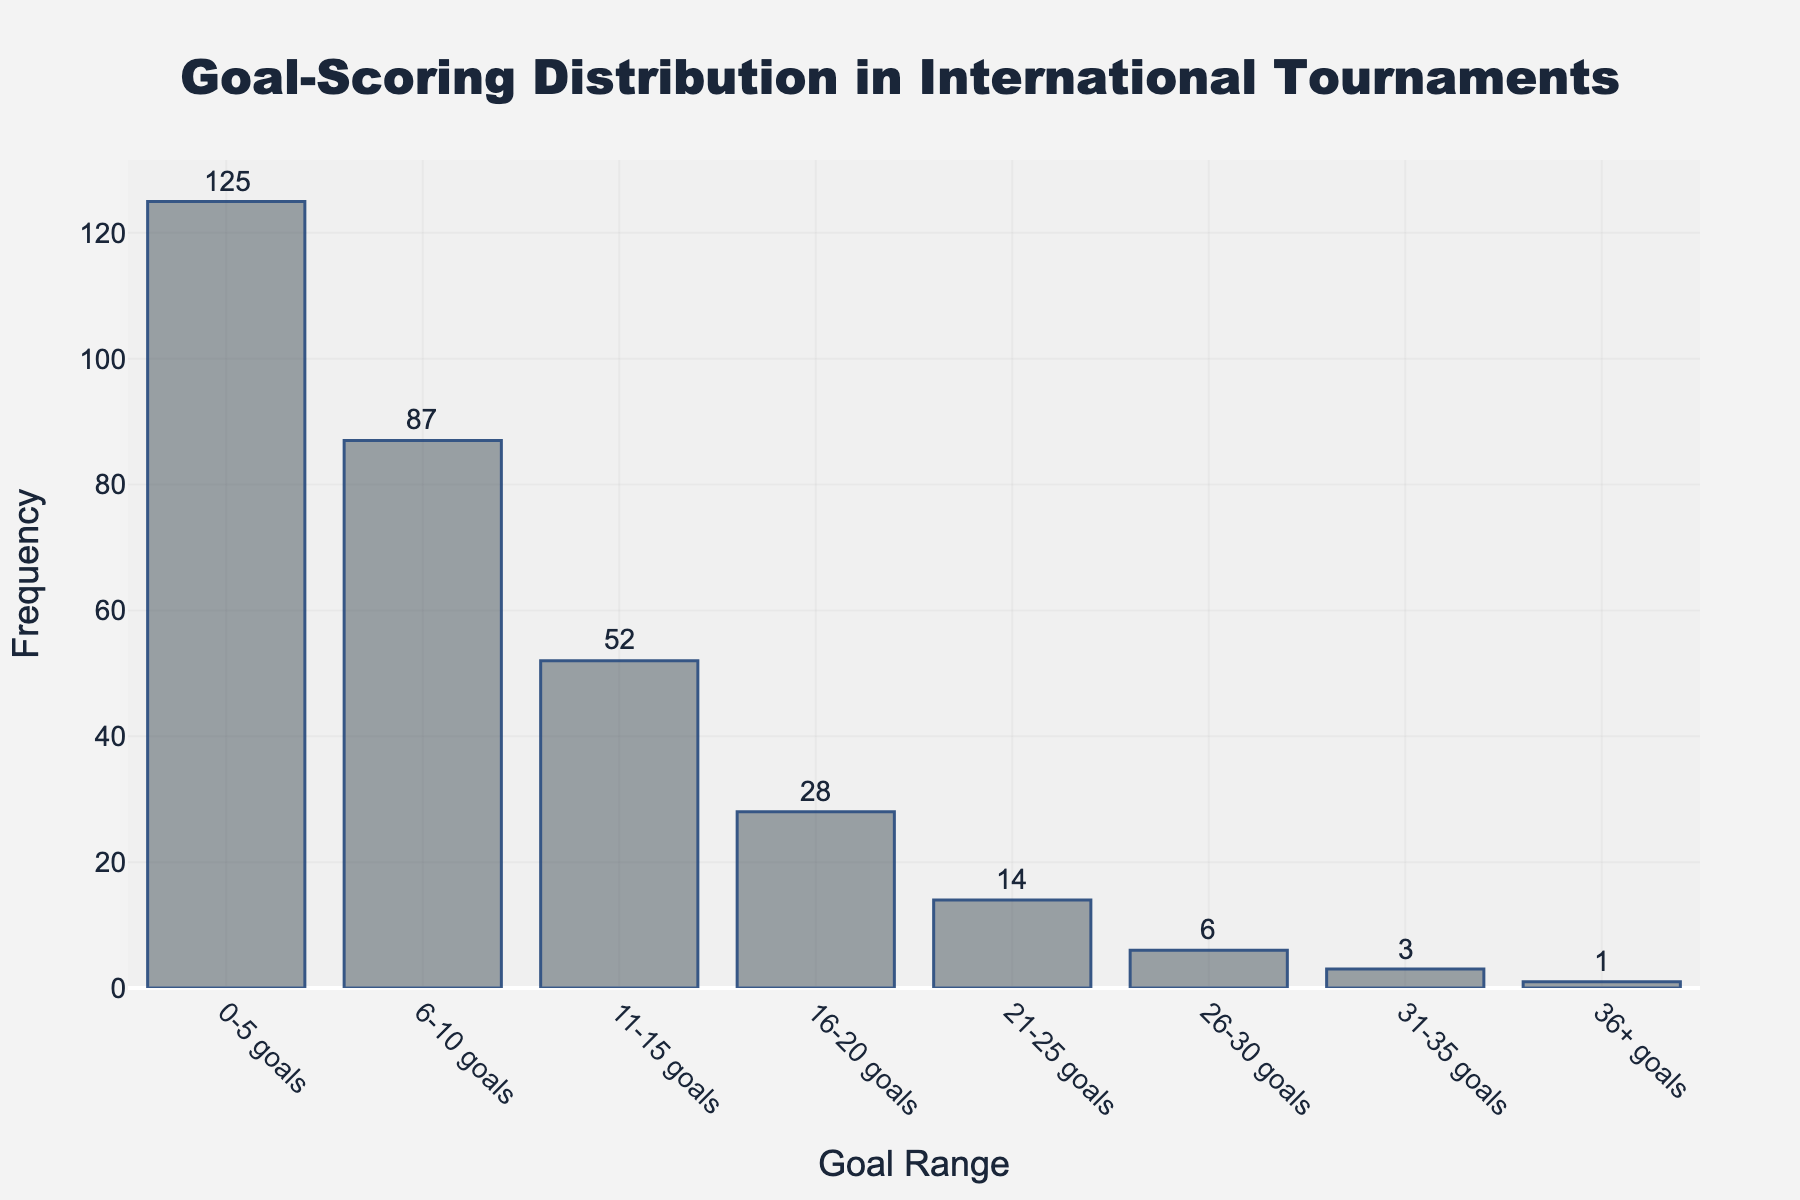what is the title of the histogram? The title of the histogram is clearly displayed at the top center of the figure. It is "Goal-Scoring Distribution in International Tournaments".
Answer: Goal-Scoring Distribution in International Tournaments What goal range has the highest frequency of strikers? The goal range with the highest frequency is the one with the tallest bar on the histogram. It's the "0-5 goals" range.
Answer: 0-5 goals How many strikers scored between 21-25 goals? To find out how many strikers scored in this range, look at the height of the bar labeled "21-25 goals", which has a frequency annotation of 14.
Answer: 14 What is the total number of strikers who scored at least 31 goals? Add the frequencies of the goal ranges "31-35 goals" and "36+ goals". The values are 3 and 1, respectively. So, 3 + 1 = 4.
Answer: 4 What is the sum of the strikers who scored between 6-10 and 11-15 goals? To find this, sum the frequencies of the "6-10 goals" and "11-15 goals" ranges. The frequencies are 87 and 52, respectively. So, 87 + 52 = 139.
Answer: 139 Which goal range shows the least frequency of strikers, and what is its value? The goal range with the least frequency is represented by the shortest bar and frequency annotation. It is the "36+ goals" range with a frequency of 1.
Answer: 36+ goals, 1 How does the frequency of the "16-20 goals" range compare to the "0-5 goals" range? Compare the frequencies of the "16-20 goals" and "0-5 goals" ranges. The "0-5 goals" range has a frequency of 125, while "16-20 goals" has a frequency of 28. So, 125 is much higher than 28.
Answer: 125 is higher than 28 What is the average number of strikers in the goal ranges of 11-15 and 16-20 goals? To calculate the average, add the frequencies of the "11-15 goals" and "16-20 goals" ranges, then divide by 2. The frequencies are 52 and 28, respectively, so (52 + 28) / 2 = 40.
Answer: 40 What percentage of strikers scored between 0-5 goals compared to the total number of strikers? First, find the total number of strikers by summing all frequencies: 125 + 87 + 52 + 28 + 14 + 6 + 3 + 1 = 316. Then, the percentage for "0-5 goals" is (125/316) * 100 ≈ 39.56%.
Answer: ≈ 39.56% How many goal ranges have a frequency of less than 30? Count the number of bars (goal ranges) with a frequency value less than 30. These ranges are: "16-20 goals" (28), "21-25 goals" (14), "26-30 goals" (6), "31-35 goals" (3), and "36+ goals" (1), totaling 5 ranges.
Answer: 5 What is the range of frequencies in the histogram? The range of frequencies is the difference between the highest and lowest frequencies. The highest frequency is 125 ("0-5 goals") and the lowest is 1 ("36+ goals"). So, 125 - 1 = 124.
Answer: 124 